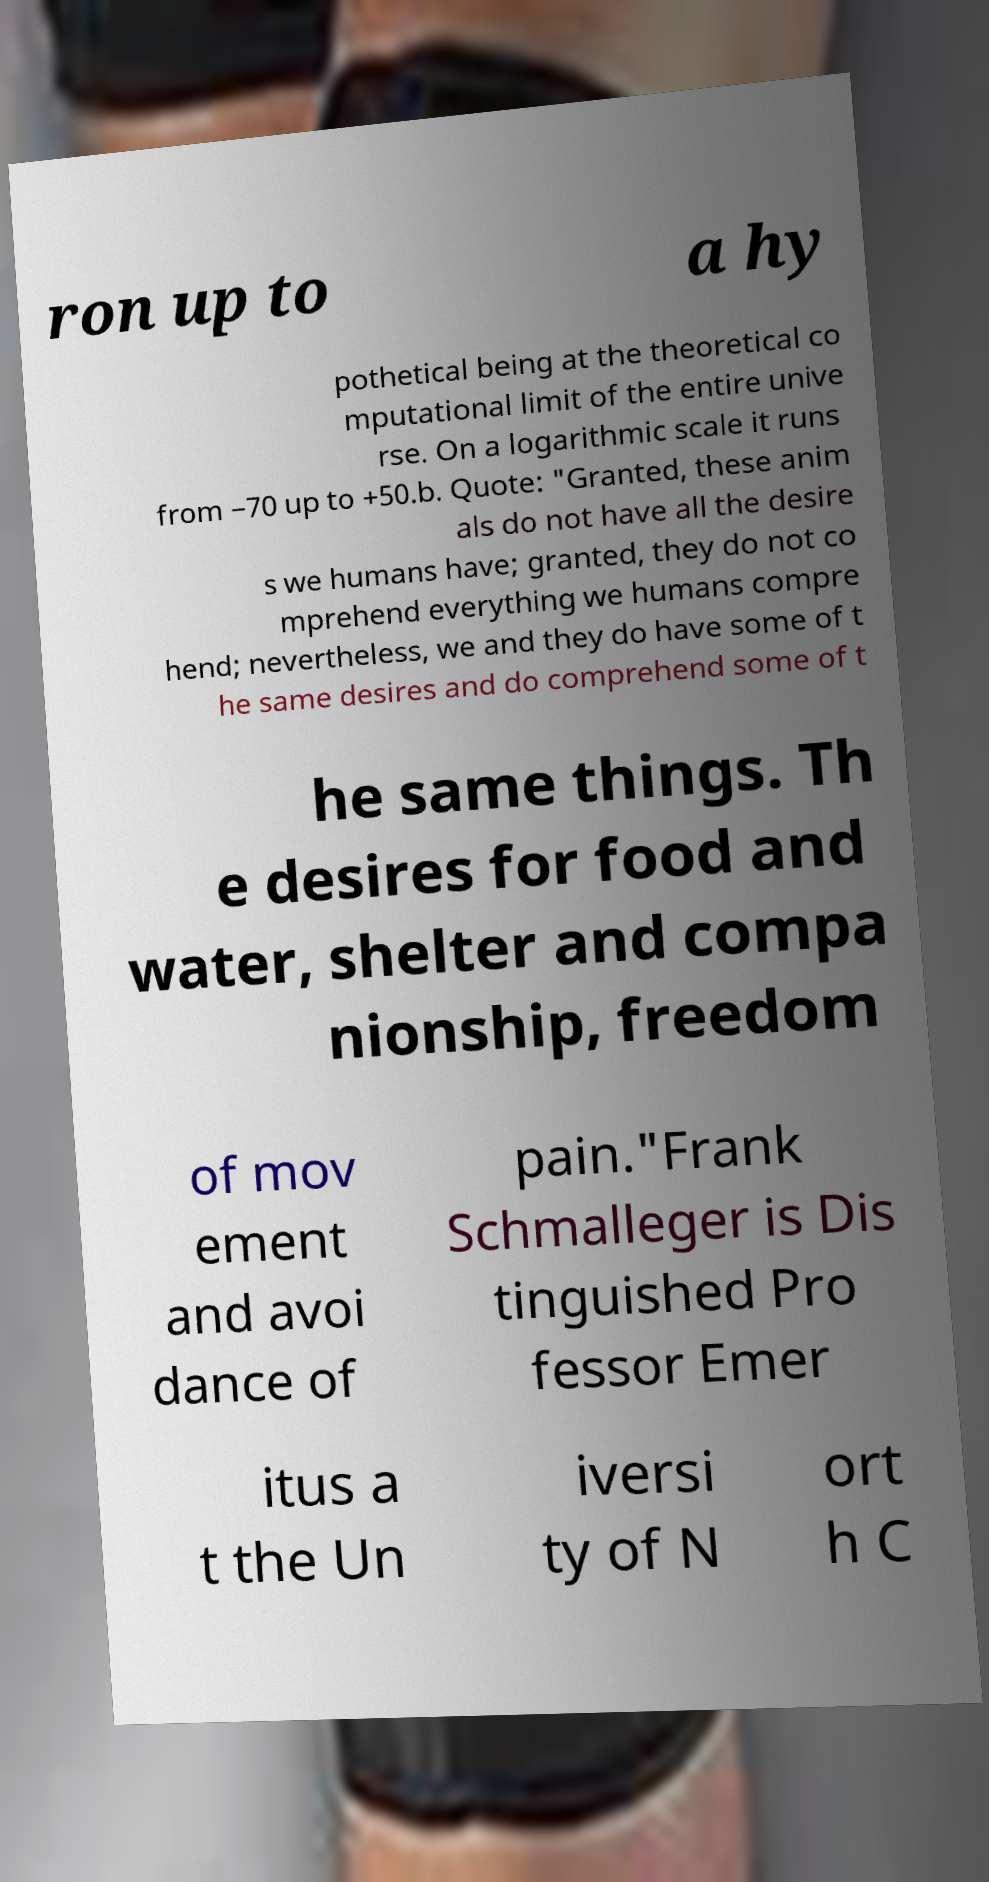Can you accurately transcribe the text from the provided image for me? ron up to a hy pothetical being at the theoretical co mputational limit of the entire unive rse. On a logarithmic scale it runs from −70 up to +50.b. Quote: "Granted, these anim als do not have all the desire s we humans have; granted, they do not co mprehend everything we humans compre hend; nevertheless, we and they do have some of t he same desires and do comprehend some of t he same things. Th e desires for food and water, shelter and compa nionship, freedom of mov ement and avoi dance of pain."Frank Schmalleger is Dis tinguished Pro fessor Emer itus a t the Un iversi ty of N ort h C 